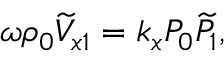<formula> <loc_0><loc_0><loc_500><loc_500>\omega \rho _ { 0 } \widetilde { V } _ { x 1 } = k _ { x } P _ { 0 } \widetilde { P } _ { 1 } ,</formula> 